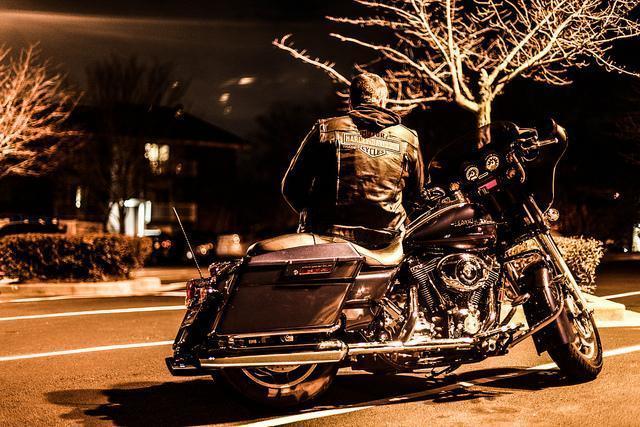How many motorcycles can be seen?
Give a very brief answer. 1. 